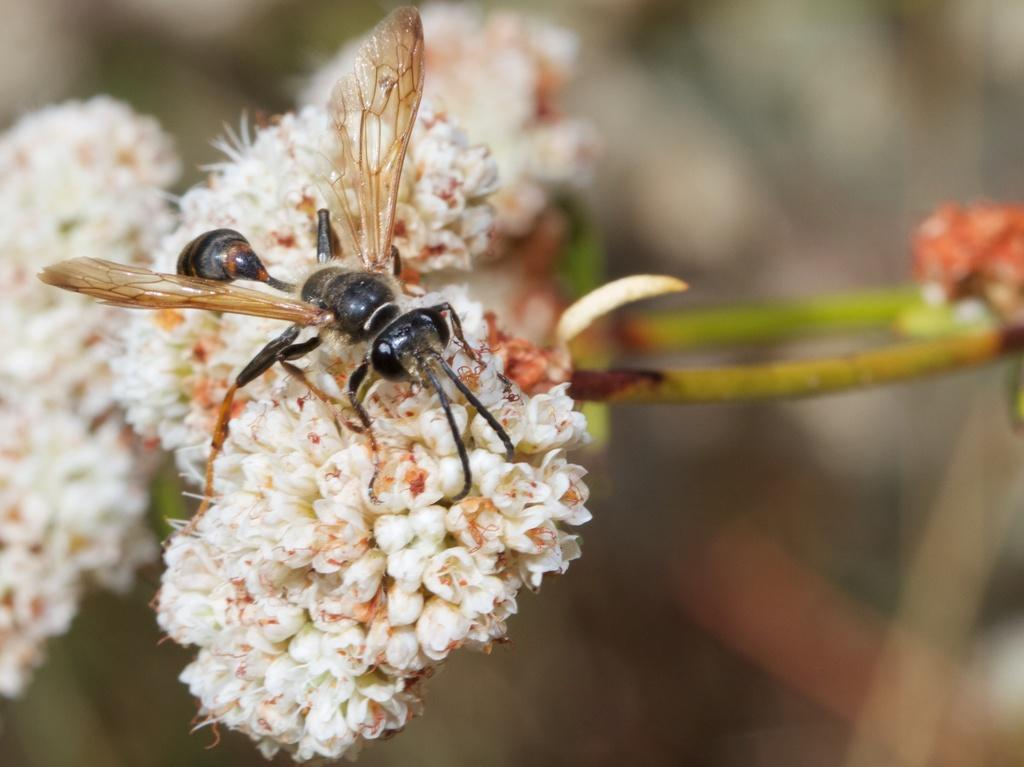What type of flowers can be seen in the image? There are white color flowers in the image. Are there any other living organisms present in the image besides the flowers? Yes, there is an insect in the image. Can you describe the background of the image? The background of the image is blurry. What type of hat is the insect wearing in the image? There is no hat present in the image, and the insect is not wearing any clothing. 